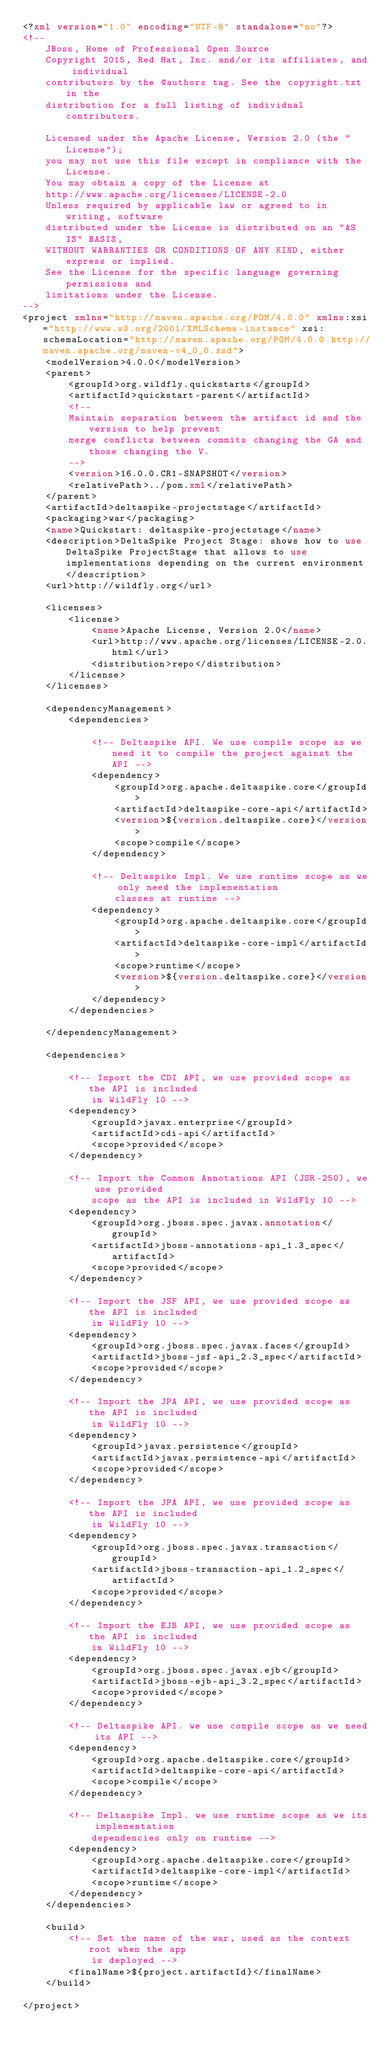Convert code to text. <code><loc_0><loc_0><loc_500><loc_500><_XML_><?xml version="1.0" encoding="UTF-8" standalone="no"?>
<!--
    JBoss, Home of Professional Open Source
    Copyright 2015, Red Hat, Inc. and/or its affiliates, and individual
    contributors by the @authors tag. See the copyright.txt in the
    distribution for a full listing of individual contributors.

    Licensed under the Apache License, Version 2.0 (the "License");
    you may not use this file except in compliance with the License.
    You may obtain a copy of the License at
    http://www.apache.org/licenses/LICENSE-2.0
    Unless required by applicable law or agreed to in writing, software
    distributed under the License is distributed on an "AS IS" BASIS,
    WITHOUT WARRANTIES OR CONDITIONS OF ANY KIND, either express or implied.
    See the License for the specific language governing permissions and
    limitations under the License.
-->
<project xmlns="http://maven.apache.org/POM/4.0.0" xmlns:xsi="http://www.w3.org/2001/XMLSchema-instance" xsi:schemaLocation="http://maven.apache.org/POM/4.0.0 http://maven.apache.org/maven-v4_0_0.xsd">
    <modelVersion>4.0.0</modelVersion>
    <parent>
        <groupId>org.wildfly.quickstarts</groupId>
        <artifactId>quickstart-parent</artifactId>
        <!--
        Maintain separation between the artifact id and the version to help prevent
        merge conflicts between commits changing the GA and those changing the V.
        -->
        <version>16.0.0.CR1-SNAPSHOT</version>
        <relativePath>../pom.xml</relativePath>
    </parent>
    <artifactId>deltaspike-projectstage</artifactId>
    <packaging>war</packaging>
    <name>Quickstart: deltaspike-projectstage</name>
    <description>DeltaSpike Project Stage: shows how to use DeltaSpike ProjectStage that allows to use implementations depending on the current environment</description>
    <url>http://wildfly.org</url>

    <licenses>
        <license>
            <name>Apache License, Version 2.0</name>
            <url>http://www.apache.org/licenses/LICENSE-2.0.html</url>
            <distribution>repo</distribution>
        </license>
    </licenses>

    <dependencyManagement>
        <dependencies>

            <!-- Deltaspike API. We use compile scope as we need it to compile the project against the API -->
            <dependency>
                <groupId>org.apache.deltaspike.core</groupId>
                <artifactId>deltaspike-core-api</artifactId>
                <version>${version.deltaspike.core}</version>
                <scope>compile</scope>
            </dependency>

            <!-- Deltaspike Impl. We use runtime scope as we only need the implementation
                classes at runtime -->
            <dependency>
                <groupId>org.apache.deltaspike.core</groupId>
                <artifactId>deltaspike-core-impl</artifactId>
                <scope>runtime</scope>
                <version>${version.deltaspike.core}</version>
            </dependency>
        </dependencies>

    </dependencyManagement>

    <dependencies>

        <!-- Import the CDI API, we use provided scope as the API is included
            in WildFly 10 -->
        <dependency>
            <groupId>javax.enterprise</groupId>
            <artifactId>cdi-api</artifactId>
            <scope>provided</scope>
        </dependency>

        <!-- Import the Common Annotations API (JSR-250), we use provided
            scope as the API is included in WildFly 10 -->
        <dependency>
            <groupId>org.jboss.spec.javax.annotation</groupId>
            <artifactId>jboss-annotations-api_1.3_spec</artifactId>
            <scope>provided</scope>
        </dependency>

        <!-- Import the JSF API, we use provided scope as the API is included
            in WildFly 10 -->
        <dependency>
            <groupId>org.jboss.spec.javax.faces</groupId>
            <artifactId>jboss-jsf-api_2.3_spec</artifactId>
            <scope>provided</scope>
        </dependency>

        <!-- Import the JPA API, we use provided scope as the API is included
            in WildFly 10 -->
        <dependency>
            <groupId>javax.persistence</groupId>
            <artifactId>javax.persistence-api</artifactId>
            <scope>provided</scope>
        </dependency>

        <!-- Import the JPA API, we use provided scope as the API is included
            in WildFly 10 -->
        <dependency>
            <groupId>org.jboss.spec.javax.transaction</groupId>
            <artifactId>jboss-transaction-api_1.2_spec</artifactId>
            <scope>provided</scope>
        </dependency>

        <!-- Import the EJB API, we use provided scope as the API is included
            in WildFly 10 -->
        <dependency>
            <groupId>org.jboss.spec.javax.ejb</groupId>
            <artifactId>jboss-ejb-api_3.2_spec</artifactId>
            <scope>provided</scope>
        </dependency>

        <!-- Deltaspike API. we use compile scope as we need its API -->
        <dependency>
            <groupId>org.apache.deltaspike.core</groupId>
            <artifactId>deltaspike-core-api</artifactId>
            <scope>compile</scope>
        </dependency>

        <!-- Deltaspike Impl. we use runtime scope as we its implementation
            dependencies only on runtime -->
        <dependency>
            <groupId>org.apache.deltaspike.core</groupId>
            <artifactId>deltaspike-core-impl</artifactId>
            <scope>runtime</scope>
        </dependency>
    </dependencies>

    <build>
        <!-- Set the name of the war, used as the context root when the app
            is deployed -->
        <finalName>${project.artifactId}</finalName>
    </build>

</project>
</code> 